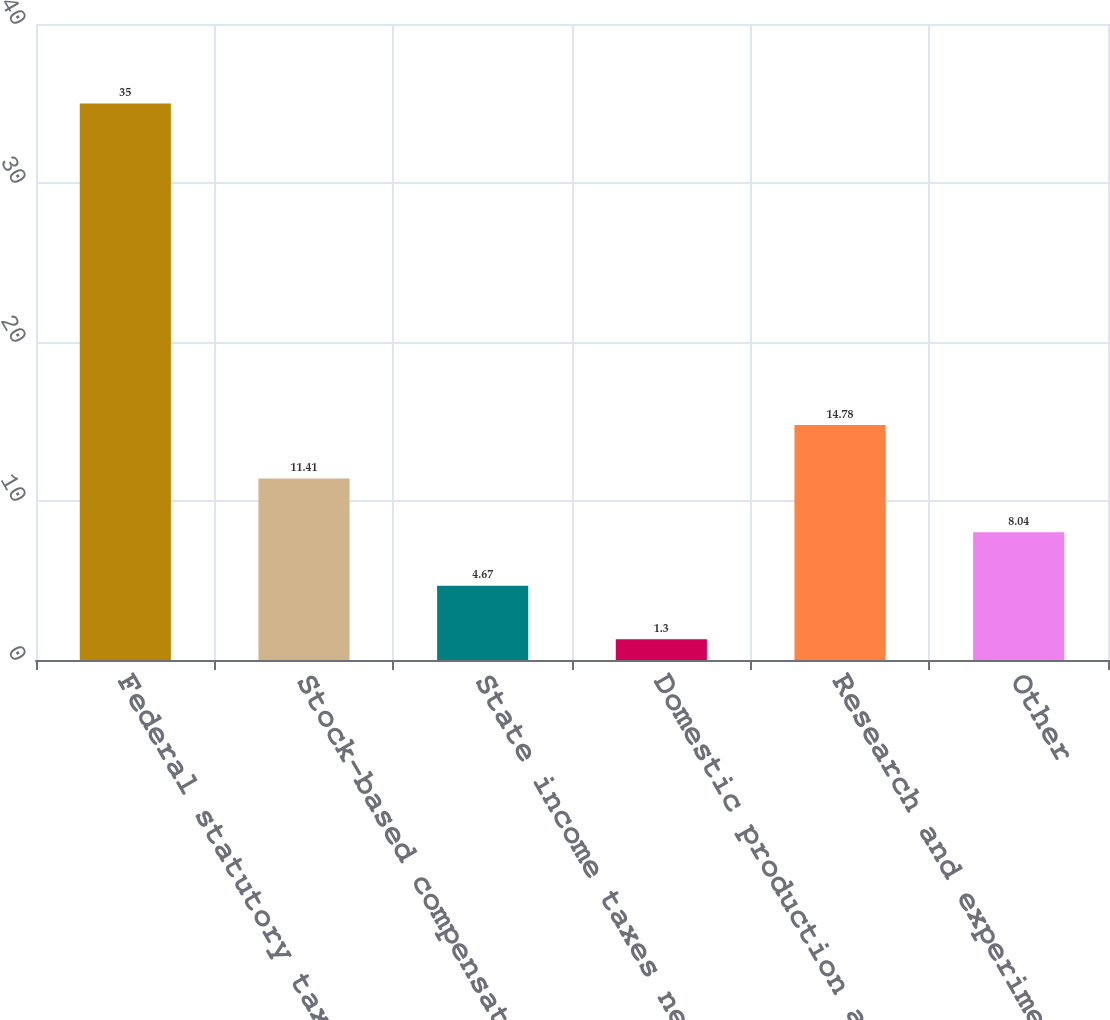Convert chart to OTSL. <chart><loc_0><loc_0><loc_500><loc_500><bar_chart><fcel>Federal statutory tax rate<fcel>Stock-based compensation<fcel>State income taxes net of<fcel>Domestic production activity<fcel>Research and experimentation<fcel>Other<nl><fcel>35<fcel>11.41<fcel>4.67<fcel>1.3<fcel>14.78<fcel>8.04<nl></chart> 